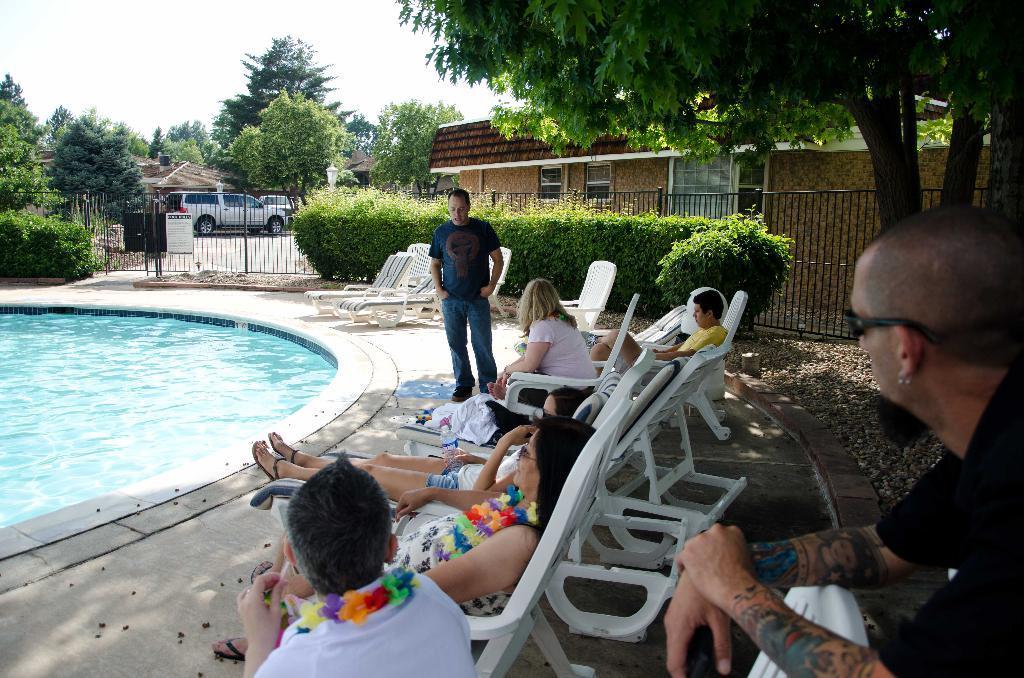Could you give a brief overview of what you see in this image? There are men and women sitting. These people are enjoying the view of swimming pool. There are many trees, plants, chairs and vehicle around. This man is wearing black shirt and he is having tattoos on his hands he is wearing goggle and a earring. 